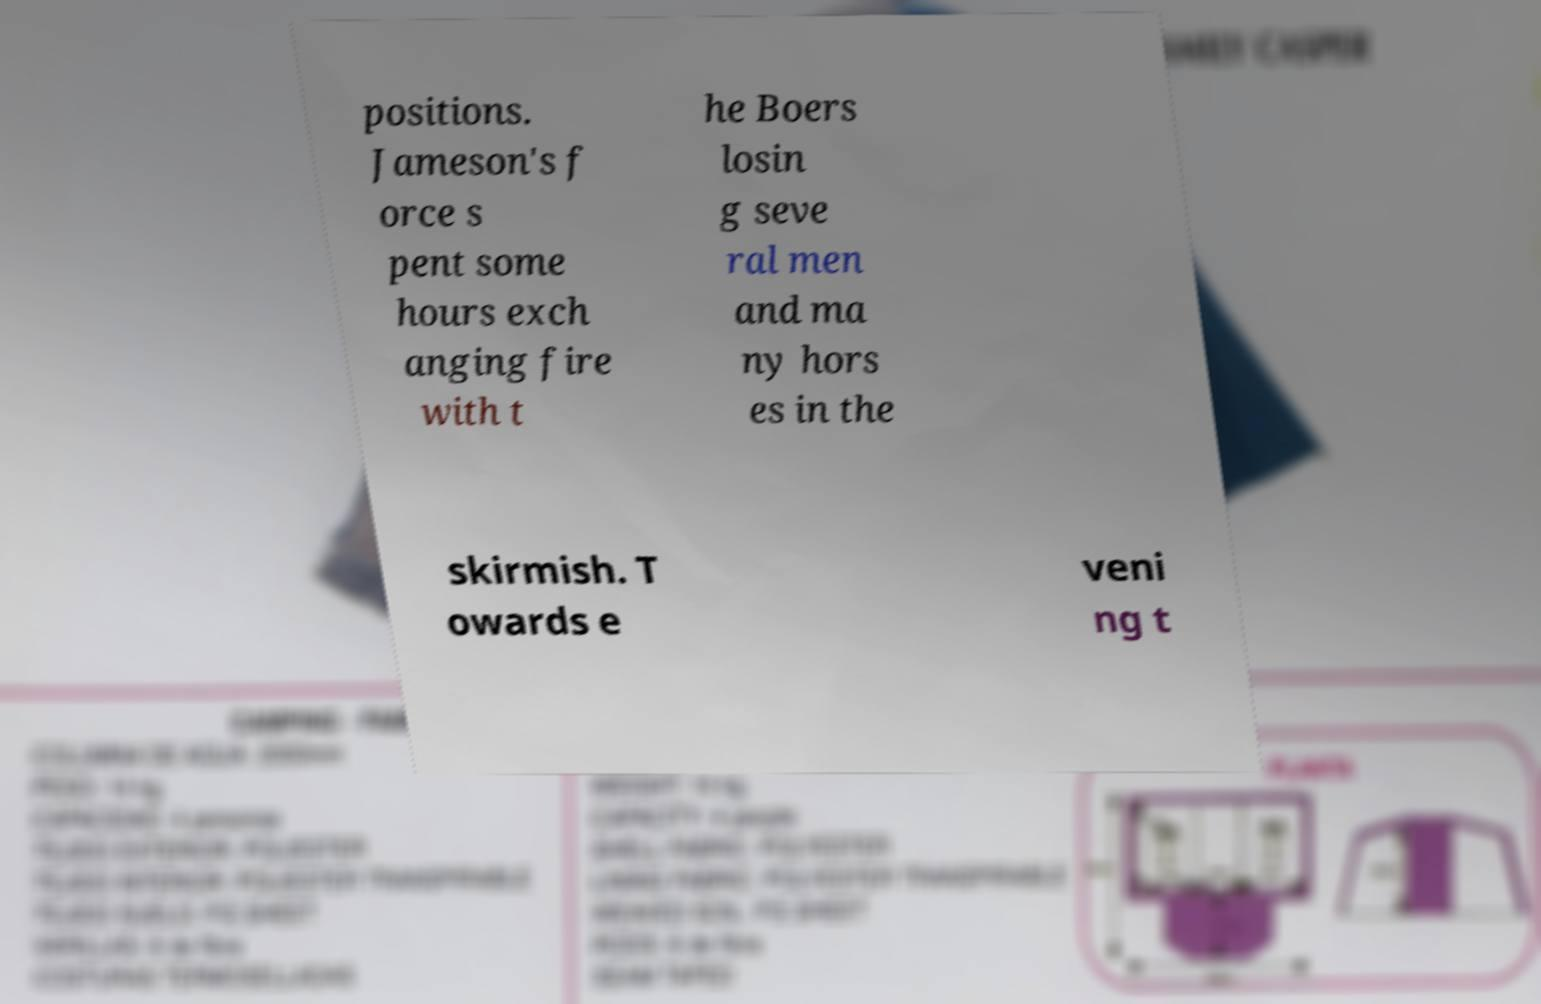Can you read and provide the text displayed in the image?This photo seems to have some interesting text. Can you extract and type it out for me? positions. Jameson's f orce s pent some hours exch anging fire with t he Boers losin g seve ral men and ma ny hors es in the skirmish. T owards e veni ng t 